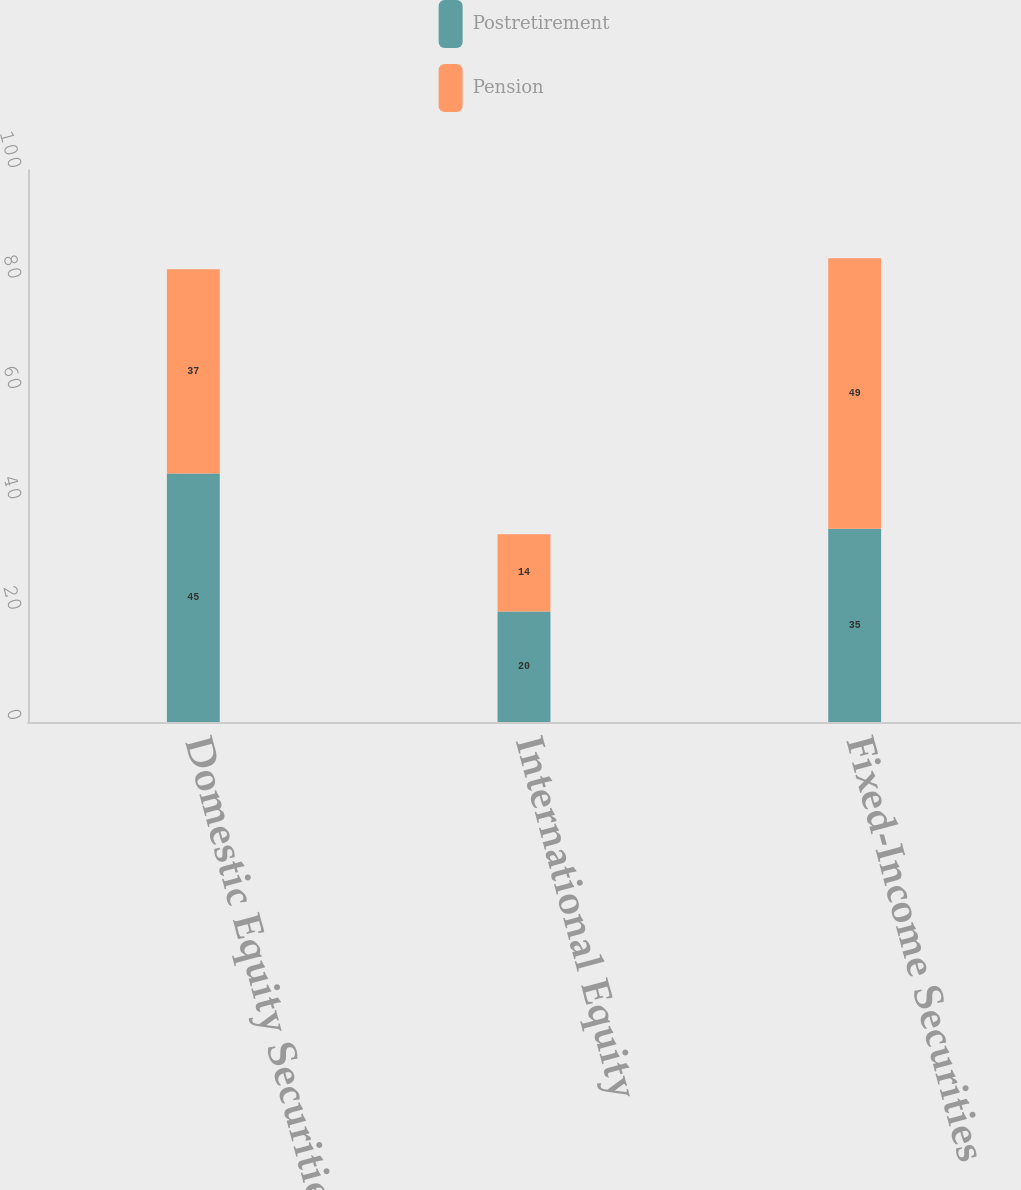Convert chart. <chart><loc_0><loc_0><loc_500><loc_500><stacked_bar_chart><ecel><fcel>Domestic Equity Securities<fcel>International Equity<fcel>Fixed-Income Securities<nl><fcel>Postretirement<fcel>45<fcel>20<fcel>35<nl><fcel>Pension<fcel>37<fcel>14<fcel>49<nl></chart> 